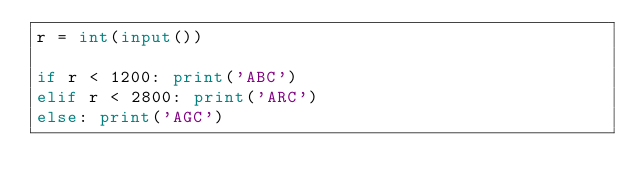<code> <loc_0><loc_0><loc_500><loc_500><_Python_>r = int(input())

if r < 1200: print('ABC')
elif r < 2800: print('ARC')
else: print('AGC')</code> 